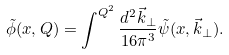Convert formula to latex. <formula><loc_0><loc_0><loc_500><loc_500>\tilde { \phi } ( x , Q ) = \int ^ { Q ^ { 2 } } \frac { d ^ { 2 } \vec { k } _ { \perp } } { 1 6 \pi ^ { 3 } } \tilde { \psi } ( x , \vec { k } _ { \perp } ) .</formula> 